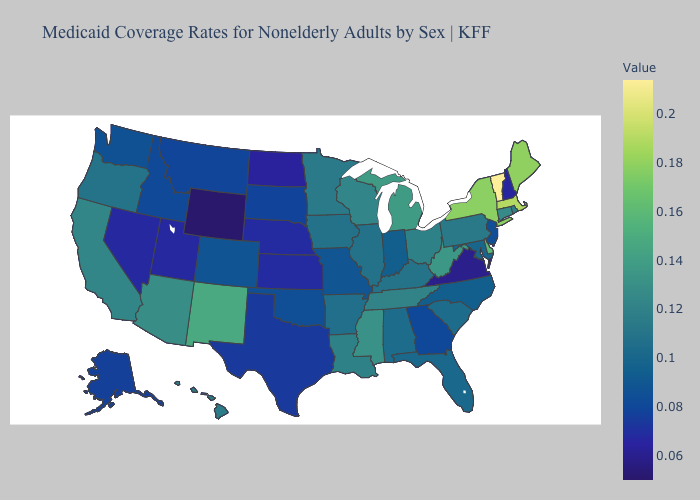Does Wyoming have the lowest value in the USA?
Quick response, please. Yes. Is the legend a continuous bar?
Short answer required. Yes. Does North Dakota have the lowest value in the MidWest?
Quick response, please. Yes. 